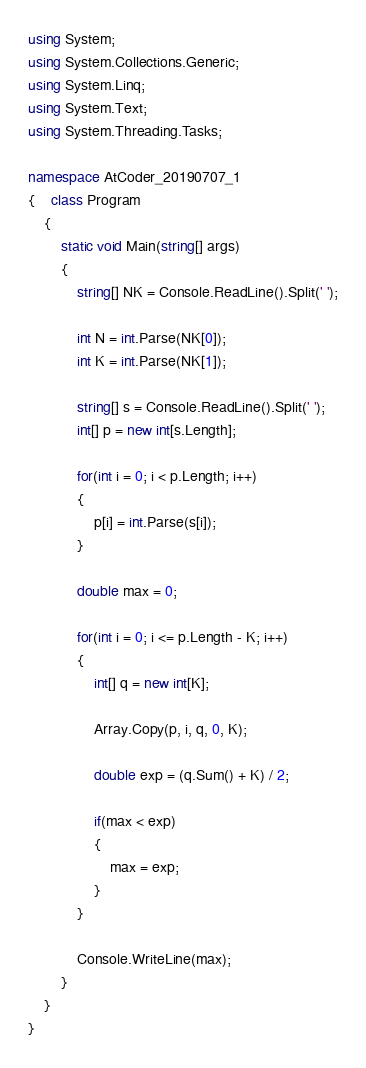Convert code to text. <code><loc_0><loc_0><loc_500><loc_500><_C#_>using System;
using System.Collections.Generic;
using System.Linq;
using System.Text;
using System.Threading.Tasks;

namespace AtCoder_20190707_1
{    class Program
    {
        static void Main(string[] args)
        {
            string[] NK = Console.ReadLine().Split(' ');

            int N = int.Parse(NK[0]);
            int K = int.Parse(NK[1]);

            string[] s = Console.ReadLine().Split(' ');
            int[] p = new int[s.Length];

            for(int i = 0; i < p.Length; i++)
            {
                p[i] = int.Parse(s[i]);
            }

            double max = 0;

            for(int i = 0; i <= p.Length - K; i++)
            {
                int[] q = new int[K];

                Array.Copy(p, i, q, 0, K);

                double exp = (q.Sum() + K) / 2;

                if(max < exp)
                {
                    max = exp;
                }
            }

            Console.WriteLine(max);
        }
    }
}</code> 